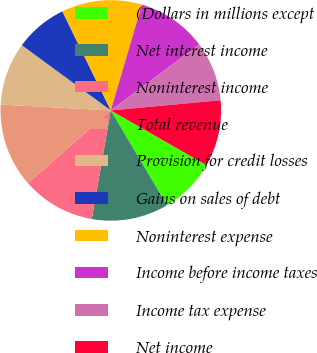Convert chart to OTSL. <chart><loc_0><loc_0><loc_500><loc_500><pie_chart><fcel>(Dollars in millions except<fcel>Net interest income<fcel>Noninterest income<fcel>Total revenue<fcel>Provision for credit losses<fcel>Gains on sales of debt<fcel>Noninterest expense<fcel>Income before income taxes<fcel>Income tax expense<fcel>Net income<nl><fcel>8.21%<fcel>11.28%<fcel>10.77%<fcel>12.31%<fcel>9.23%<fcel>7.69%<fcel>11.79%<fcel>10.26%<fcel>8.72%<fcel>9.74%<nl></chart> 